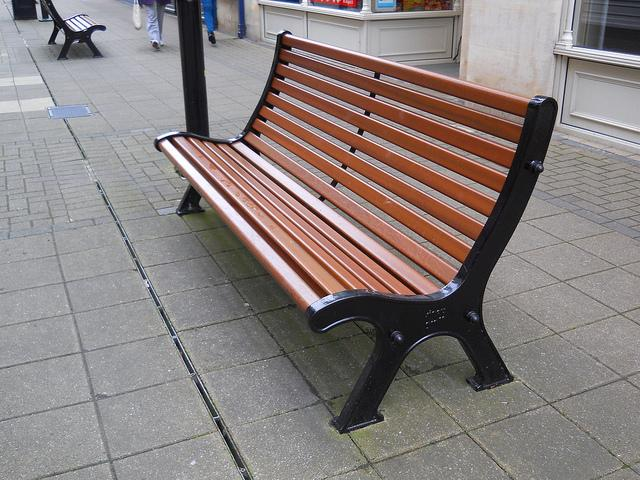This bench is located where? Please explain your reasoning. city sidewalk. People walk along the street. benches are placed along streets for people. 